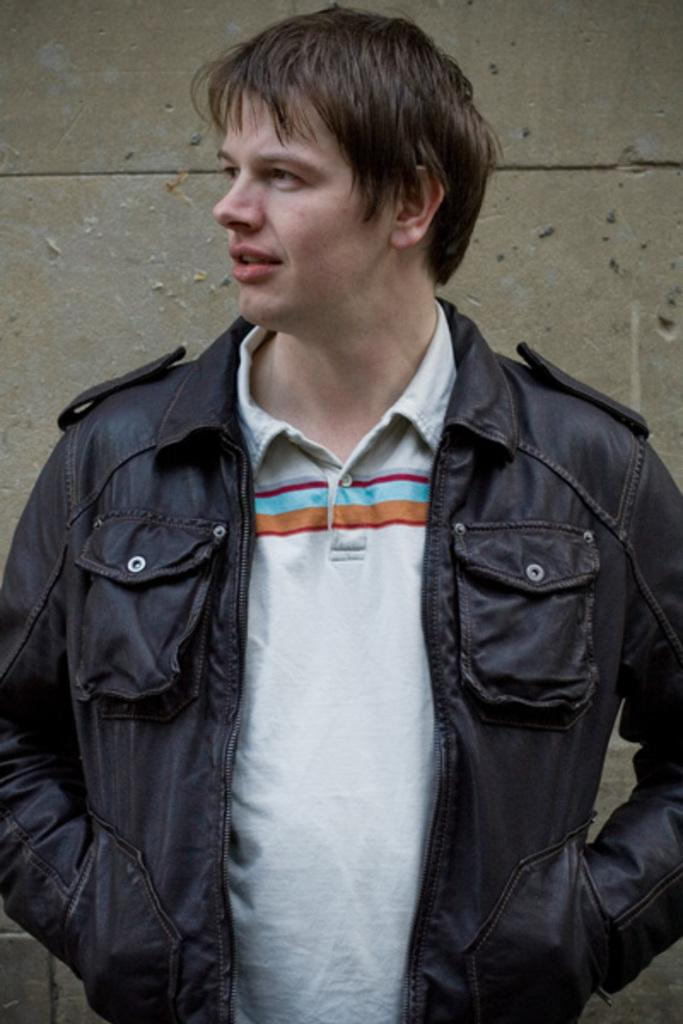What is the main subject of the image? There is a man standing in the center of the image. What is the man wearing? The man is wearing a jacket. What can be seen in the background of the image? There is a wall visible in the background of the image. How many bikes are parked next to the man in the image? There are no bikes present in the image. What type of bread is the man holding in the image? The man is not holding any bread in the image. 